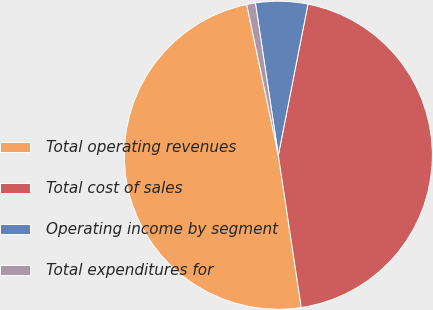Convert chart. <chart><loc_0><loc_0><loc_500><loc_500><pie_chart><fcel>Total operating revenues<fcel>Total cost of sales<fcel>Operating income by segment<fcel>Total expenditures for<nl><fcel>49.09%<fcel>44.54%<fcel>5.46%<fcel>0.91%<nl></chart> 